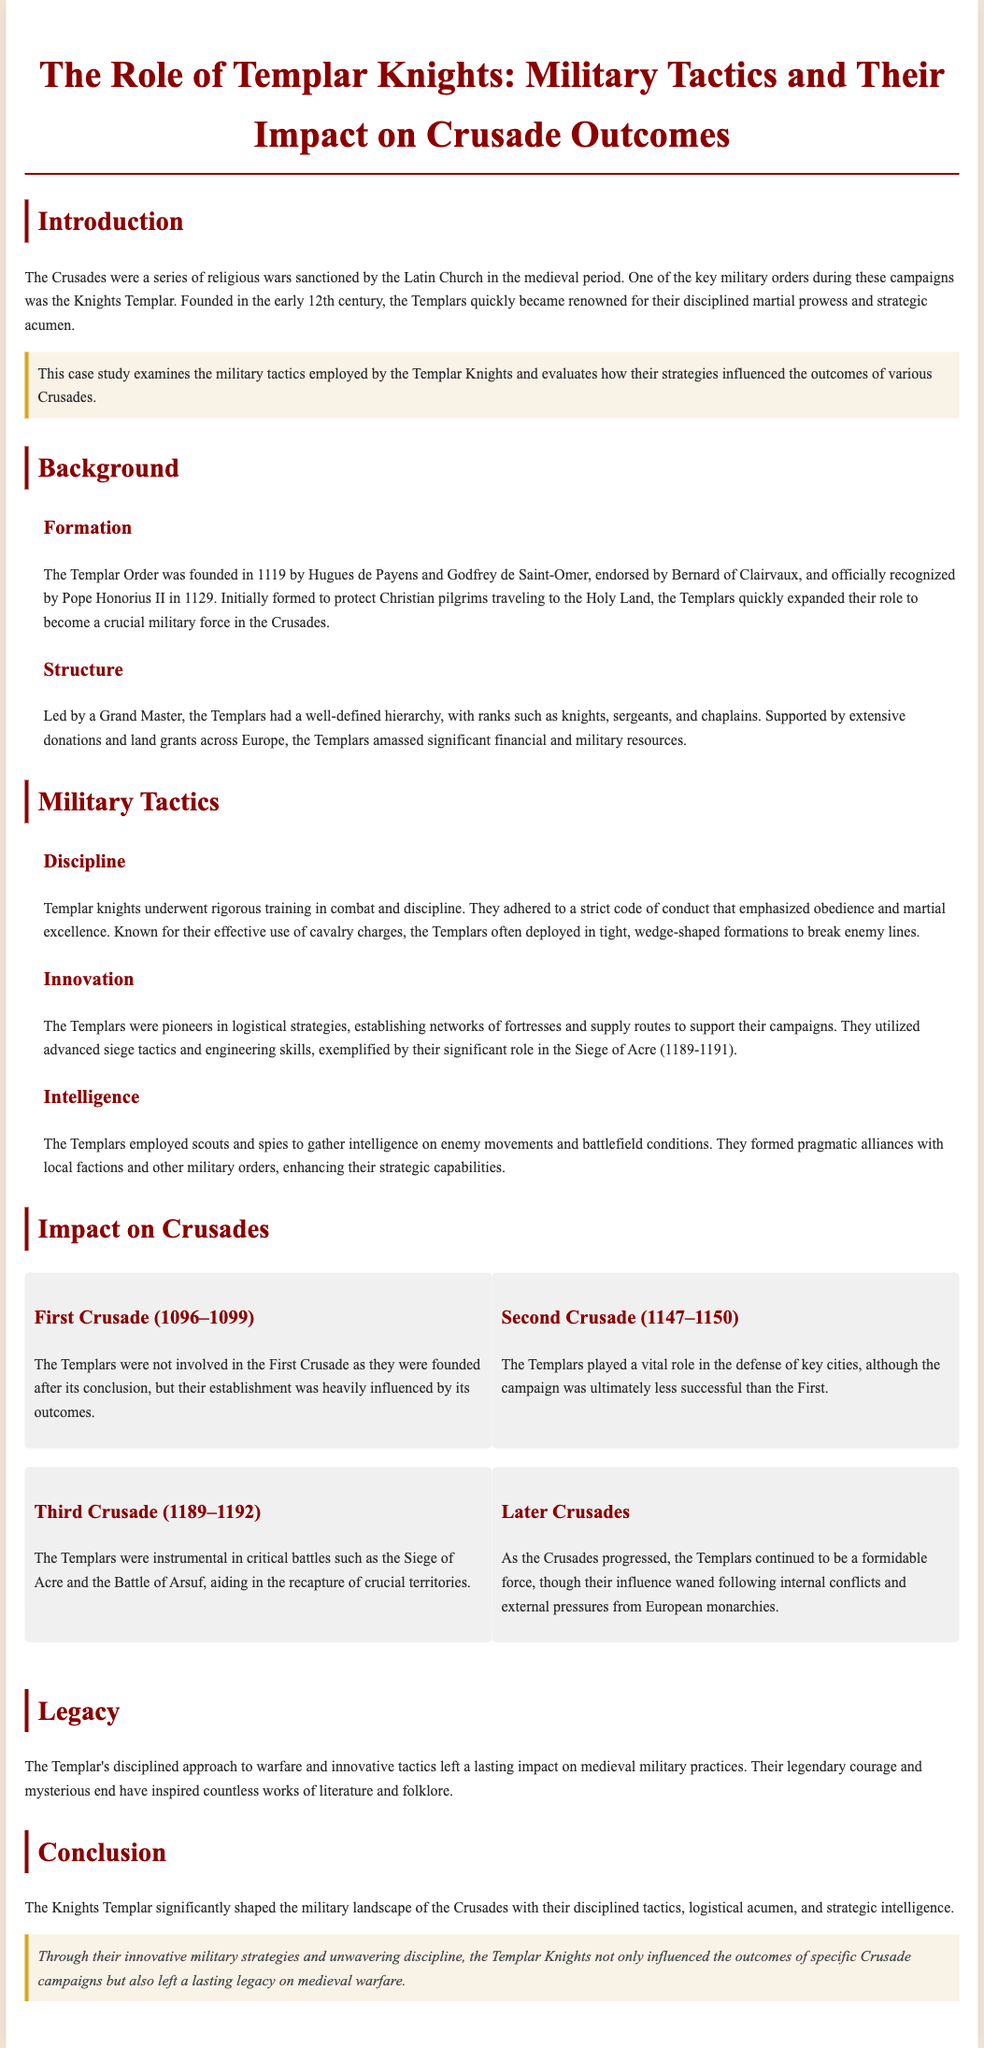What year was the Templar Order founded? The Templar Order was founded in 1119.
Answer: 1119 Who endorsed the Templar Order's founding? Bernard of Clairvaux endorsed the founding of the Templar Order.
Answer: Bernard of Clairvaux What was one of the military tactics utilized by the Templars? The Templars utilized effective cavalry charges as one of their military tactics.
Answer: Cavalry charges In which Crusade did the Templars play a vital role in the defense of key cities? The Templars played a vital role in the Second Crusade.
Answer: Second Crusade What was a significant event the Templars were involved in during the Third Crusade? The Templars were instrumental in the Siege of Acre.
Answer: Siege of Acre What was the legacy of the Templar Knights according to the document? The legacy of the Templar Knights includes their disciplined approach to warfare and lasting impact on medieval military practices.
Answer: Disciplined approach to warfare What military strategy did the Templars innovate according to the case study? The Templars innovated logistical strategies, establishing networks of fortresses and supply routes.
Answer: Logistical strategies What title was held by the leader of the Templar Knights? The title held by the leader of the Templar Knights was Grand Master.
Answer: Grand Master How did the Templars gather intelligence during the Crusades? The Templars gathered intelligence by employing scouts and spies.
Answer: Scouts and spies 